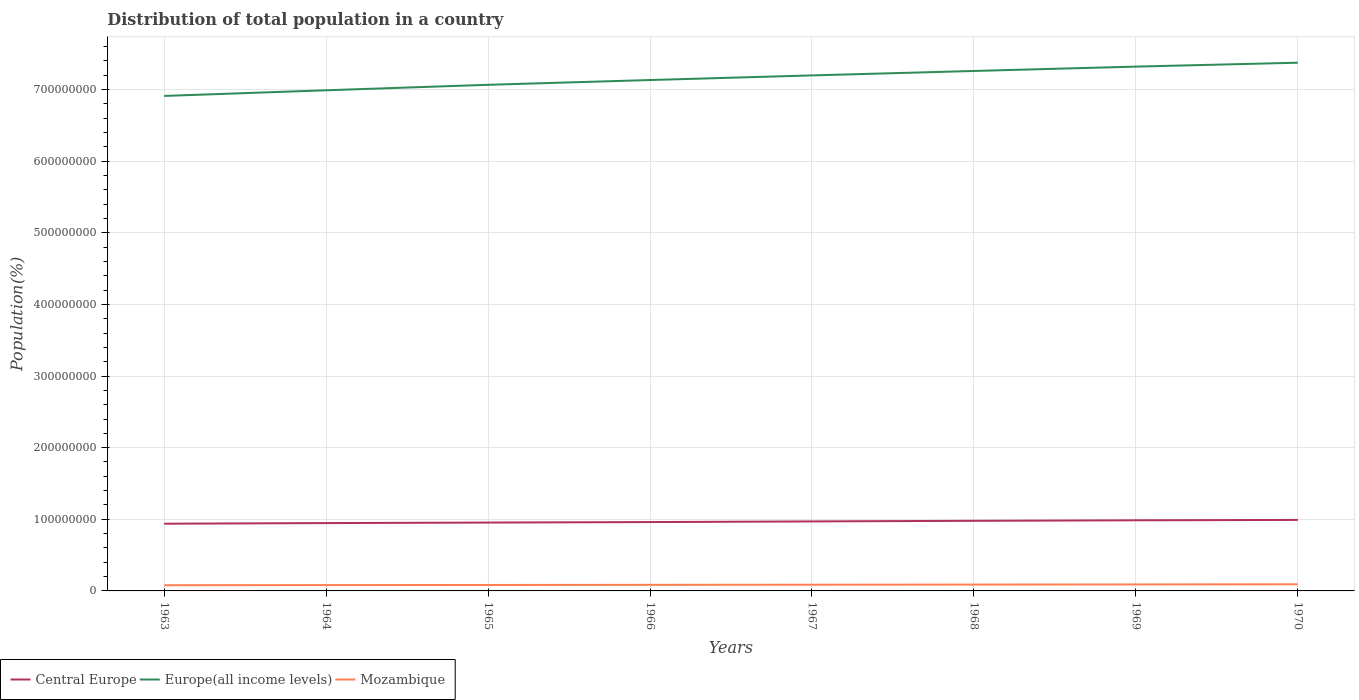How many different coloured lines are there?
Your answer should be compact. 3. Does the line corresponding to Mozambique intersect with the line corresponding to Central Europe?
Make the answer very short. No. Is the number of lines equal to the number of legend labels?
Your answer should be compact. Yes. Across all years, what is the maximum population of in Central Europe?
Give a very brief answer. 9.38e+07. In which year was the population of in Europe(all income levels) maximum?
Your response must be concise. 1963. What is the total population of in Mozambique in the graph?
Your answer should be very brief. -1.98e+05. What is the difference between the highest and the second highest population of in Central Europe?
Provide a short and direct response. 5.29e+06. Is the population of in Mozambique strictly greater than the population of in Europe(all income levels) over the years?
Provide a short and direct response. Yes. How many lines are there?
Provide a short and direct response. 3. What is the difference between two consecutive major ticks on the Y-axis?
Provide a succinct answer. 1.00e+08. Are the values on the major ticks of Y-axis written in scientific E-notation?
Your answer should be compact. No. Does the graph contain any zero values?
Offer a terse response. No. Does the graph contain grids?
Your answer should be compact. Yes. Where does the legend appear in the graph?
Your answer should be compact. Bottom left. How many legend labels are there?
Provide a succinct answer. 3. What is the title of the graph?
Your answer should be compact. Distribution of total population in a country. What is the label or title of the X-axis?
Ensure brevity in your answer.  Years. What is the label or title of the Y-axis?
Provide a succinct answer. Population(%). What is the Population(%) in Central Europe in 1963?
Keep it short and to the point. 9.38e+07. What is the Population(%) of Europe(all income levels) in 1963?
Provide a succinct answer. 6.91e+08. What is the Population(%) of Mozambique in 1963?
Offer a terse response. 7.96e+06. What is the Population(%) of Central Europe in 1964?
Your answer should be very brief. 9.47e+07. What is the Population(%) of Europe(all income levels) in 1964?
Your answer should be very brief. 6.99e+08. What is the Population(%) of Mozambique in 1964?
Your response must be concise. 8.13e+06. What is the Population(%) in Central Europe in 1965?
Offer a terse response. 9.54e+07. What is the Population(%) in Europe(all income levels) in 1965?
Ensure brevity in your answer.  7.07e+08. What is the Population(%) in Mozambique in 1965?
Provide a short and direct response. 8.30e+06. What is the Population(%) in Central Europe in 1966?
Ensure brevity in your answer.  9.61e+07. What is the Population(%) of Europe(all income levels) in 1966?
Offer a very short reply. 7.13e+08. What is the Population(%) in Mozambique in 1966?
Provide a short and direct response. 8.48e+06. What is the Population(%) in Central Europe in 1967?
Give a very brief answer. 9.70e+07. What is the Population(%) of Europe(all income levels) in 1967?
Keep it short and to the point. 7.20e+08. What is the Population(%) in Mozambique in 1967?
Offer a terse response. 8.67e+06. What is the Population(%) of Central Europe in 1968?
Your answer should be very brief. 9.79e+07. What is the Population(%) in Europe(all income levels) in 1968?
Keep it short and to the point. 7.26e+08. What is the Population(%) in Mozambique in 1968?
Give a very brief answer. 8.86e+06. What is the Population(%) of Central Europe in 1969?
Provide a succinct answer. 9.86e+07. What is the Population(%) of Europe(all income levels) in 1969?
Give a very brief answer. 7.32e+08. What is the Population(%) in Mozambique in 1969?
Make the answer very short. 9.06e+06. What is the Population(%) of Central Europe in 1970?
Offer a very short reply. 9.91e+07. What is the Population(%) of Europe(all income levels) in 1970?
Keep it short and to the point. 7.38e+08. What is the Population(%) of Mozambique in 1970?
Make the answer very short. 9.26e+06. Across all years, what is the maximum Population(%) in Central Europe?
Ensure brevity in your answer.  9.91e+07. Across all years, what is the maximum Population(%) in Europe(all income levels)?
Ensure brevity in your answer.  7.38e+08. Across all years, what is the maximum Population(%) in Mozambique?
Offer a terse response. 9.26e+06. Across all years, what is the minimum Population(%) of Central Europe?
Your answer should be compact. 9.38e+07. Across all years, what is the minimum Population(%) in Europe(all income levels)?
Ensure brevity in your answer.  6.91e+08. Across all years, what is the minimum Population(%) of Mozambique?
Provide a succinct answer. 7.96e+06. What is the total Population(%) in Central Europe in the graph?
Ensure brevity in your answer.  7.73e+08. What is the total Population(%) in Europe(all income levels) in the graph?
Provide a short and direct response. 5.73e+09. What is the total Population(%) of Mozambique in the graph?
Offer a terse response. 6.87e+07. What is the difference between the Population(%) in Central Europe in 1963 and that in 1964?
Your response must be concise. -8.77e+05. What is the difference between the Population(%) in Europe(all income levels) in 1963 and that in 1964?
Offer a very short reply. -7.90e+06. What is the difference between the Population(%) in Mozambique in 1963 and that in 1964?
Provide a succinct answer. -1.68e+05. What is the difference between the Population(%) in Central Europe in 1963 and that in 1965?
Your answer should be compact. -1.60e+06. What is the difference between the Population(%) in Europe(all income levels) in 1963 and that in 1965?
Provide a short and direct response. -1.55e+07. What is the difference between the Population(%) in Mozambique in 1963 and that in 1965?
Keep it short and to the point. -3.41e+05. What is the difference between the Population(%) of Central Europe in 1963 and that in 1966?
Make the answer very short. -2.30e+06. What is the difference between the Population(%) of Europe(all income levels) in 1963 and that in 1966?
Keep it short and to the point. -2.22e+07. What is the difference between the Population(%) of Mozambique in 1963 and that in 1966?
Offer a terse response. -5.21e+05. What is the difference between the Population(%) of Central Europe in 1963 and that in 1967?
Ensure brevity in your answer.  -3.20e+06. What is the difference between the Population(%) in Europe(all income levels) in 1963 and that in 1967?
Provide a short and direct response. -2.87e+07. What is the difference between the Population(%) of Mozambique in 1963 and that in 1967?
Ensure brevity in your answer.  -7.07e+05. What is the difference between the Population(%) in Central Europe in 1963 and that in 1968?
Provide a short and direct response. -4.04e+06. What is the difference between the Population(%) in Europe(all income levels) in 1963 and that in 1968?
Provide a succinct answer. -3.48e+07. What is the difference between the Population(%) of Mozambique in 1963 and that in 1968?
Your response must be concise. -8.99e+05. What is the difference between the Population(%) in Central Europe in 1963 and that in 1969?
Ensure brevity in your answer.  -4.76e+06. What is the difference between the Population(%) of Europe(all income levels) in 1963 and that in 1969?
Offer a very short reply. -4.09e+07. What is the difference between the Population(%) in Mozambique in 1963 and that in 1969?
Offer a very short reply. -1.10e+06. What is the difference between the Population(%) of Central Europe in 1963 and that in 1970?
Your answer should be very brief. -5.29e+06. What is the difference between the Population(%) of Europe(all income levels) in 1963 and that in 1970?
Make the answer very short. -4.64e+07. What is the difference between the Population(%) of Mozambique in 1963 and that in 1970?
Provide a succinct answer. -1.30e+06. What is the difference between the Population(%) of Central Europe in 1964 and that in 1965?
Offer a terse response. -7.24e+05. What is the difference between the Population(%) of Europe(all income levels) in 1964 and that in 1965?
Provide a succinct answer. -7.64e+06. What is the difference between the Population(%) in Mozambique in 1964 and that in 1965?
Provide a short and direct response. -1.73e+05. What is the difference between the Population(%) of Central Europe in 1964 and that in 1966?
Your answer should be very brief. -1.43e+06. What is the difference between the Population(%) of Europe(all income levels) in 1964 and that in 1966?
Provide a succinct answer. -1.43e+07. What is the difference between the Population(%) of Mozambique in 1964 and that in 1966?
Provide a short and direct response. -3.53e+05. What is the difference between the Population(%) of Central Europe in 1964 and that in 1967?
Ensure brevity in your answer.  -2.32e+06. What is the difference between the Population(%) in Europe(all income levels) in 1964 and that in 1967?
Provide a succinct answer. -2.08e+07. What is the difference between the Population(%) of Mozambique in 1964 and that in 1967?
Provide a short and direct response. -5.39e+05. What is the difference between the Population(%) in Central Europe in 1964 and that in 1968?
Provide a succinct answer. -3.16e+06. What is the difference between the Population(%) of Europe(all income levels) in 1964 and that in 1968?
Make the answer very short. -2.70e+07. What is the difference between the Population(%) of Mozambique in 1964 and that in 1968?
Your response must be concise. -7.32e+05. What is the difference between the Population(%) in Central Europe in 1964 and that in 1969?
Your answer should be compact. -3.88e+06. What is the difference between the Population(%) of Europe(all income levels) in 1964 and that in 1969?
Provide a succinct answer. -3.30e+07. What is the difference between the Population(%) in Mozambique in 1964 and that in 1969?
Make the answer very short. -9.29e+05. What is the difference between the Population(%) of Central Europe in 1964 and that in 1970?
Ensure brevity in your answer.  -4.41e+06. What is the difference between the Population(%) of Europe(all income levels) in 1964 and that in 1970?
Provide a succinct answer. -3.85e+07. What is the difference between the Population(%) of Mozambique in 1964 and that in 1970?
Offer a very short reply. -1.13e+06. What is the difference between the Population(%) of Central Europe in 1965 and that in 1966?
Give a very brief answer. -7.02e+05. What is the difference between the Population(%) in Europe(all income levels) in 1965 and that in 1966?
Offer a terse response. -6.66e+06. What is the difference between the Population(%) in Mozambique in 1965 and that in 1966?
Offer a very short reply. -1.80e+05. What is the difference between the Population(%) of Central Europe in 1965 and that in 1967?
Provide a short and direct response. -1.60e+06. What is the difference between the Population(%) in Europe(all income levels) in 1965 and that in 1967?
Your answer should be very brief. -1.31e+07. What is the difference between the Population(%) in Mozambique in 1965 and that in 1967?
Provide a short and direct response. -3.66e+05. What is the difference between the Population(%) in Central Europe in 1965 and that in 1968?
Keep it short and to the point. -2.44e+06. What is the difference between the Population(%) of Europe(all income levels) in 1965 and that in 1968?
Offer a very short reply. -1.93e+07. What is the difference between the Population(%) in Mozambique in 1965 and that in 1968?
Ensure brevity in your answer.  -5.58e+05. What is the difference between the Population(%) in Central Europe in 1965 and that in 1969?
Make the answer very short. -3.16e+06. What is the difference between the Population(%) in Europe(all income levels) in 1965 and that in 1969?
Keep it short and to the point. -2.54e+07. What is the difference between the Population(%) in Mozambique in 1965 and that in 1969?
Provide a succinct answer. -7.56e+05. What is the difference between the Population(%) in Central Europe in 1965 and that in 1970?
Keep it short and to the point. -3.69e+06. What is the difference between the Population(%) of Europe(all income levels) in 1965 and that in 1970?
Your response must be concise. -3.09e+07. What is the difference between the Population(%) of Mozambique in 1965 and that in 1970?
Ensure brevity in your answer.  -9.59e+05. What is the difference between the Population(%) in Central Europe in 1966 and that in 1967?
Provide a short and direct response. -8.95e+05. What is the difference between the Population(%) of Europe(all income levels) in 1966 and that in 1967?
Offer a terse response. -6.45e+06. What is the difference between the Population(%) in Mozambique in 1966 and that in 1967?
Your answer should be compact. -1.86e+05. What is the difference between the Population(%) of Central Europe in 1966 and that in 1968?
Provide a succinct answer. -1.73e+06. What is the difference between the Population(%) of Europe(all income levels) in 1966 and that in 1968?
Provide a short and direct response. -1.26e+07. What is the difference between the Population(%) of Mozambique in 1966 and that in 1968?
Give a very brief answer. -3.78e+05. What is the difference between the Population(%) of Central Europe in 1966 and that in 1969?
Your response must be concise. -2.45e+06. What is the difference between the Population(%) of Europe(all income levels) in 1966 and that in 1969?
Ensure brevity in your answer.  -1.87e+07. What is the difference between the Population(%) of Mozambique in 1966 and that in 1969?
Offer a terse response. -5.76e+05. What is the difference between the Population(%) in Central Europe in 1966 and that in 1970?
Provide a short and direct response. -2.98e+06. What is the difference between the Population(%) in Europe(all income levels) in 1966 and that in 1970?
Provide a succinct answer. -2.42e+07. What is the difference between the Population(%) of Mozambique in 1966 and that in 1970?
Your answer should be compact. -7.80e+05. What is the difference between the Population(%) of Central Europe in 1967 and that in 1968?
Your answer should be very brief. -8.39e+05. What is the difference between the Population(%) of Europe(all income levels) in 1967 and that in 1968?
Your answer should be very brief. -6.20e+06. What is the difference between the Population(%) of Mozambique in 1967 and that in 1968?
Offer a very short reply. -1.92e+05. What is the difference between the Population(%) of Central Europe in 1967 and that in 1969?
Ensure brevity in your answer.  -1.56e+06. What is the difference between the Population(%) of Europe(all income levels) in 1967 and that in 1969?
Your answer should be very brief. -1.23e+07. What is the difference between the Population(%) of Mozambique in 1967 and that in 1969?
Give a very brief answer. -3.90e+05. What is the difference between the Population(%) of Central Europe in 1967 and that in 1970?
Make the answer very short. -2.09e+06. What is the difference between the Population(%) of Europe(all income levels) in 1967 and that in 1970?
Your response must be concise. -1.77e+07. What is the difference between the Population(%) in Mozambique in 1967 and that in 1970?
Your response must be concise. -5.94e+05. What is the difference between the Population(%) of Central Europe in 1968 and that in 1969?
Offer a very short reply. -7.20e+05. What is the difference between the Population(%) of Europe(all income levels) in 1968 and that in 1969?
Ensure brevity in your answer.  -6.10e+06. What is the difference between the Population(%) of Mozambique in 1968 and that in 1969?
Provide a short and direct response. -1.98e+05. What is the difference between the Population(%) of Central Europe in 1968 and that in 1970?
Ensure brevity in your answer.  -1.25e+06. What is the difference between the Population(%) in Europe(all income levels) in 1968 and that in 1970?
Ensure brevity in your answer.  -1.16e+07. What is the difference between the Population(%) in Mozambique in 1968 and that in 1970?
Offer a very short reply. -4.01e+05. What is the difference between the Population(%) in Central Europe in 1969 and that in 1970?
Offer a terse response. -5.31e+05. What is the difference between the Population(%) in Europe(all income levels) in 1969 and that in 1970?
Ensure brevity in your answer.  -5.46e+06. What is the difference between the Population(%) of Mozambique in 1969 and that in 1970?
Offer a very short reply. -2.03e+05. What is the difference between the Population(%) of Central Europe in 1963 and the Population(%) of Europe(all income levels) in 1964?
Make the answer very short. -6.05e+08. What is the difference between the Population(%) of Central Europe in 1963 and the Population(%) of Mozambique in 1964?
Keep it short and to the point. 8.57e+07. What is the difference between the Population(%) of Europe(all income levels) in 1963 and the Population(%) of Mozambique in 1964?
Ensure brevity in your answer.  6.83e+08. What is the difference between the Population(%) of Central Europe in 1963 and the Population(%) of Europe(all income levels) in 1965?
Ensure brevity in your answer.  -6.13e+08. What is the difference between the Population(%) of Central Europe in 1963 and the Population(%) of Mozambique in 1965?
Provide a short and direct response. 8.55e+07. What is the difference between the Population(%) in Europe(all income levels) in 1963 and the Population(%) in Mozambique in 1965?
Offer a terse response. 6.83e+08. What is the difference between the Population(%) of Central Europe in 1963 and the Population(%) of Europe(all income levels) in 1966?
Offer a very short reply. -6.19e+08. What is the difference between the Population(%) in Central Europe in 1963 and the Population(%) in Mozambique in 1966?
Offer a very short reply. 8.54e+07. What is the difference between the Population(%) in Europe(all income levels) in 1963 and the Population(%) in Mozambique in 1966?
Give a very brief answer. 6.83e+08. What is the difference between the Population(%) of Central Europe in 1963 and the Population(%) of Europe(all income levels) in 1967?
Give a very brief answer. -6.26e+08. What is the difference between the Population(%) of Central Europe in 1963 and the Population(%) of Mozambique in 1967?
Give a very brief answer. 8.52e+07. What is the difference between the Population(%) in Europe(all income levels) in 1963 and the Population(%) in Mozambique in 1967?
Your answer should be very brief. 6.82e+08. What is the difference between the Population(%) of Central Europe in 1963 and the Population(%) of Europe(all income levels) in 1968?
Offer a terse response. -6.32e+08. What is the difference between the Population(%) in Central Europe in 1963 and the Population(%) in Mozambique in 1968?
Your response must be concise. 8.50e+07. What is the difference between the Population(%) of Europe(all income levels) in 1963 and the Population(%) of Mozambique in 1968?
Keep it short and to the point. 6.82e+08. What is the difference between the Population(%) in Central Europe in 1963 and the Population(%) in Europe(all income levels) in 1969?
Offer a terse response. -6.38e+08. What is the difference between the Population(%) of Central Europe in 1963 and the Population(%) of Mozambique in 1969?
Ensure brevity in your answer.  8.48e+07. What is the difference between the Population(%) in Europe(all income levels) in 1963 and the Population(%) in Mozambique in 1969?
Your answer should be very brief. 6.82e+08. What is the difference between the Population(%) of Central Europe in 1963 and the Population(%) of Europe(all income levels) in 1970?
Ensure brevity in your answer.  -6.44e+08. What is the difference between the Population(%) in Central Europe in 1963 and the Population(%) in Mozambique in 1970?
Ensure brevity in your answer.  8.46e+07. What is the difference between the Population(%) in Europe(all income levels) in 1963 and the Population(%) in Mozambique in 1970?
Your response must be concise. 6.82e+08. What is the difference between the Population(%) of Central Europe in 1964 and the Population(%) of Europe(all income levels) in 1965?
Your answer should be very brief. -6.12e+08. What is the difference between the Population(%) in Central Europe in 1964 and the Population(%) in Mozambique in 1965?
Offer a very short reply. 8.64e+07. What is the difference between the Population(%) of Europe(all income levels) in 1964 and the Population(%) of Mozambique in 1965?
Offer a terse response. 6.91e+08. What is the difference between the Population(%) of Central Europe in 1964 and the Population(%) of Europe(all income levels) in 1966?
Your answer should be compact. -6.19e+08. What is the difference between the Population(%) in Central Europe in 1964 and the Population(%) in Mozambique in 1966?
Provide a short and direct response. 8.62e+07. What is the difference between the Population(%) in Europe(all income levels) in 1964 and the Population(%) in Mozambique in 1966?
Make the answer very short. 6.91e+08. What is the difference between the Population(%) in Central Europe in 1964 and the Population(%) in Europe(all income levels) in 1967?
Keep it short and to the point. -6.25e+08. What is the difference between the Population(%) of Central Europe in 1964 and the Population(%) of Mozambique in 1967?
Ensure brevity in your answer.  8.61e+07. What is the difference between the Population(%) in Europe(all income levels) in 1964 and the Population(%) in Mozambique in 1967?
Your answer should be very brief. 6.90e+08. What is the difference between the Population(%) of Central Europe in 1964 and the Population(%) of Europe(all income levels) in 1968?
Your answer should be very brief. -6.31e+08. What is the difference between the Population(%) in Central Europe in 1964 and the Population(%) in Mozambique in 1968?
Your response must be concise. 8.59e+07. What is the difference between the Population(%) in Europe(all income levels) in 1964 and the Population(%) in Mozambique in 1968?
Make the answer very short. 6.90e+08. What is the difference between the Population(%) in Central Europe in 1964 and the Population(%) in Europe(all income levels) in 1969?
Provide a succinct answer. -6.37e+08. What is the difference between the Population(%) of Central Europe in 1964 and the Population(%) of Mozambique in 1969?
Offer a very short reply. 8.57e+07. What is the difference between the Population(%) in Europe(all income levels) in 1964 and the Population(%) in Mozambique in 1969?
Your answer should be very brief. 6.90e+08. What is the difference between the Population(%) in Central Europe in 1964 and the Population(%) in Europe(all income levels) in 1970?
Provide a succinct answer. -6.43e+08. What is the difference between the Population(%) of Central Europe in 1964 and the Population(%) of Mozambique in 1970?
Offer a terse response. 8.55e+07. What is the difference between the Population(%) of Europe(all income levels) in 1964 and the Population(%) of Mozambique in 1970?
Give a very brief answer. 6.90e+08. What is the difference between the Population(%) of Central Europe in 1965 and the Population(%) of Europe(all income levels) in 1966?
Ensure brevity in your answer.  -6.18e+08. What is the difference between the Population(%) of Central Europe in 1965 and the Population(%) of Mozambique in 1966?
Ensure brevity in your answer.  8.70e+07. What is the difference between the Population(%) in Europe(all income levels) in 1965 and the Population(%) in Mozambique in 1966?
Offer a very short reply. 6.98e+08. What is the difference between the Population(%) in Central Europe in 1965 and the Population(%) in Europe(all income levels) in 1967?
Offer a terse response. -6.24e+08. What is the difference between the Population(%) of Central Europe in 1965 and the Population(%) of Mozambique in 1967?
Offer a terse response. 8.68e+07. What is the difference between the Population(%) of Europe(all income levels) in 1965 and the Population(%) of Mozambique in 1967?
Keep it short and to the point. 6.98e+08. What is the difference between the Population(%) of Central Europe in 1965 and the Population(%) of Europe(all income levels) in 1968?
Keep it short and to the point. -6.31e+08. What is the difference between the Population(%) in Central Europe in 1965 and the Population(%) in Mozambique in 1968?
Offer a terse response. 8.66e+07. What is the difference between the Population(%) in Europe(all income levels) in 1965 and the Population(%) in Mozambique in 1968?
Offer a very short reply. 6.98e+08. What is the difference between the Population(%) of Central Europe in 1965 and the Population(%) of Europe(all income levels) in 1969?
Provide a succinct answer. -6.37e+08. What is the difference between the Population(%) of Central Europe in 1965 and the Population(%) of Mozambique in 1969?
Keep it short and to the point. 8.64e+07. What is the difference between the Population(%) in Europe(all income levels) in 1965 and the Population(%) in Mozambique in 1969?
Your answer should be compact. 6.98e+08. What is the difference between the Population(%) in Central Europe in 1965 and the Population(%) in Europe(all income levels) in 1970?
Ensure brevity in your answer.  -6.42e+08. What is the difference between the Population(%) of Central Europe in 1965 and the Population(%) of Mozambique in 1970?
Provide a succinct answer. 8.62e+07. What is the difference between the Population(%) in Europe(all income levels) in 1965 and the Population(%) in Mozambique in 1970?
Your answer should be very brief. 6.97e+08. What is the difference between the Population(%) in Central Europe in 1966 and the Population(%) in Europe(all income levels) in 1967?
Make the answer very short. -6.24e+08. What is the difference between the Population(%) in Central Europe in 1966 and the Population(%) in Mozambique in 1967?
Offer a very short reply. 8.75e+07. What is the difference between the Population(%) in Europe(all income levels) in 1966 and the Population(%) in Mozambique in 1967?
Your answer should be very brief. 7.05e+08. What is the difference between the Population(%) in Central Europe in 1966 and the Population(%) in Europe(all income levels) in 1968?
Keep it short and to the point. -6.30e+08. What is the difference between the Population(%) in Central Europe in 1966 and the Population(%) in Mozambique in 1968?
Give a very brief answer. 8.73e+07. What is the difference between the Population(%) of Europe(all income levels) in 1966 and the Population(%) of Mozambique in 1968?
Your answer should be very brief. 7.04e+08. What is the difference between the Population(%) in Central Europe in 1966 and the Population(%) in Europe(all income levels) in 1969?
Make the answer very short. -6.36e+08. What is the difference between the Population(%) in Central Europe in 1966 and the Population(%) in Mozambique in 1969?
Offer a very short reply. 8.71e+07. What is the difference between the Population(%) of Europe(all income levels) in 1966 and the Population(%) of Mozambique in 1969?
Ensure brevity in your answer.  7.04e+08. What is the difference between the Population(%) in Central Europe in 1966 and the Population(%) in Europe(all income levels) in 1970?
Your answer should be compact. -6.41e+08. What is the difference between the Population(%) of Central Europe in 1966 and the Population(%) of Mozambique in 1970?
Make the answer very short. 8.69e+07. What is the difference between the Population(%) of Europe(all income levels) in 1966 and the Population(%) of Mozambique in 1970?
Ensure brevity in your answer.  7.04e+08. What is the difference between the Population(%) in Central Europe in 1967 and the Population(%) in Europe(all income levels) in 1968?
Offer a terse response. -6.29e+08. What is the difference between the Population(%) in Central Europe in 1967 and the Population(%) in Mozambique in 1968?
Your answer should be compact. 8.82e+07. What is the difference between the Population(%) of Europe(all income levels) in 1967 and the Population(%) of Mozambique in 1968?
Offer a terse response. 7.11e+08. What is the difference between the Population(%) of Central Europe in 1967 and the Population(%) of Europe(all income levels) in 1969?
Your response must be concise. -6.35e+08. What is the difference between the Population(%) of Central Europe in 1967 and the Population(%) of Mozambique in 1969?
Your answer should be compact. 8.80e+07. What is the difference between the Population(%) of Europe(all income levels) in 1967 and the Population(%) of Mozambique in 1969?
Give a very brief answer. 7.11e+08. What is the difference between the Population(%) of Central Europe in 1967 and the Population(%) of Europe(all income levels) in 1970?
Keep it short and to the point. -6.40e+08. What is the difference between the Population(%) of Central Europe in 1967 and the Population(%) of Mozambique in 1970?
Your response must be concise. 8.78e+07. What is the difference between the Population(%) in Europe(all income levels) in 1967 and the Population(%) in Mozambique in 1970?
Provide a short and direct response. 7.10e+08. What is the difference between the Population(%) in Central Europe in 1968 and the Population(%) in Europe(all income levels) in 1969?
Your answer should be very brief. -6.34e+08. What is the difference between the Population(%) in Central Europe in 1968 and the Population(%) in Mozambique in 1969?
Provide a succinct answer. 8.88e+07. What is the difference between the Population(%) in Europe(all income levels) in 1968 and the Population(%) in Mozambique in 1969?
Provide a short and direct response. 7.17e+08. What is the difference between the Population(%) of Central Europe in 1968 and the Population(%) of Europe(all income levels) in 1970?
Give a very brief answer. -6.40e+08. What is the difference between the Population(%) in Central Europe in 1968 and the Population(%) in Mozambique in 1970?
Provide a succinct answer. 8.86e+07. What is the difference between the Population(%) of Europe(all income levels) in 1968 and the Population(%) of Mozambique in 1970?
Offer a very short reply. 7.17e+08. What is the difference between the Population(%) of Central Europe in 1969 and the Population(%) of Europe(all income levels) in 1970?
Your answer should be very brief. -6.39e+08. What is the difference between the Population(%) in Central Europe in 1969 and the Population(%) in Mozambique in 1970?
Offer a terse response. 8.93e+07. What is the difference between the Population(%) of Europe(all income levels) in 1969 and the Population(%) of Mozambique in 1970?
Provide a succinct answer. 7.23e+08. What is the average Population(%) of Central Europe per year?
Your response must be concise. 9.66e+07. What is the average Population(%) of Europe(all income levels) per year?
Give a very brief answer. 7.16e+08. What is the average Population(%) of Mozambique per year?
Make the answer very short. 8.59e+06. In the year 1963, what is the difference between the Population(%) in Central Europe and Population(%) in Europe(all income levels)?
Provide a succinct answer. -5.97e+08. In the year 1963, what is the difference between the Population(%) of Central Europe and Population(%) of Mozambique?
Offer a very short reply. 8.59e+07. In the year 1963, what is the difference between the Population(%) of Europe(all income levels) and Population(%) of Mozambique?
Offer a very short reply. 6.83e+08. In the year 1964, what is the difference between the Population(%) in Central Europe and Population(%) in Europe(all income levels)?
Ensure brevity in your answer.  -6.04e+08. In the year 1964, what is the difference between the Population(%) in Central Europe and Population(%) in Mozambique?
Offer a very short reply. 8.66e+07. In the year 1964, what is the difference between the Population(%) in Europe(all income levels) and Population(%) in Mozambique?
Your answer should be very brief. 6.91e+08. In the year 1965, what is the difference between the Population(%) in Central Europe and Population(%) in Europe(all income levels)?
Provide a succinct answer. -6.11e+08. In the year 1965, what is the difference between the Population(%) of Central Europe and Population(%) of Mozambique?
Your response must be concise. 8.71e+07. In the year 1965, what is the difference between the Population(%) of Europe(all income levels) and Population(%) of Mozambique?
Provide a short and direct response. 6.98e+08. In the year 1966, what is the difference between the Population(%) of Central Europe and Population(%) of Europe(all income levels)?
Offer a very short reply. -6.17e+08. In the year 1966, what is the difference between the Population(%) in Central Europe and Population(%) in Mozambique?
Keep it short and to the point. 8.77e+07. In the year 1966, what is the difference between the Population(%) of Europe(all income levels) and Population(%) of Mozambique?
Provide a short and direct response. 7.05e+08. In the year 1967, what is the difference between the Population(%) in Central Europe and Population(%) in Europe(all income levels)?
Offer a terse response. -6.23e+08. In the year 1967, what is the difference between the Population(%) of Central Europe and Population(%) of Mozambique?
Your answer should be very brief. 8.84e+07. In the year 1967, what is the difference between the Population(%) of Europe(all income levels) and Population(%) of Mozambique?
Offer a very short reply. 7.11e+08. In the year 1968, what is the difference between the Population(%) of Central Europe and Population(%) of Europe(all income levels)?
Make the answer very short. -6.28e+08. In the year 1968, what is the difference between the Population(%) of Central Europe and Population(%) of Mozambique?
Your answer should be compact. 8.90e+07. In the year 1968, what is the difference between the Population(%) in Europe(all income levels) and Population(%) in Mozambique?
Keep it short and to the point. 7.17e+08. In the year 1969, what is the difference between the Population(%) in Central Europe and Population(%) in Europe(all income levels)?
Provide a succinct answer. -6.33e+08. In the year 1969, what is the difference between the Population(%) of Central Europe and Population(%) of Mozambique?
Keep it short and to the point. 8.95e+07. In the year 1969, what is the difference between the Population(%) in Europe(all income levels) and Population(%) in Mozambique?
Give a very brief answer. 7.23e+08. In the year 1970, what is the difference between the Population(%) of Central Europe and Population(%) of Europe(all income levels)?
Your answer should be very brief. -6.38e+08. In the year 1970, what is the difference between the Population(%) of Central Europe and Population(%) of Mozambique?
Your answer should be compact. 8.99e+07. In the year 1970, what is the difference between the Population(%) of Europe(all income levels) and Population(%) of Mozambique?
Make the answer very short. 7.28e+08. What is the ratio of the Population(%) in Europe(all income levels) in 1963 to that in 1964?
Provide a short and direct response. 0.99. What is the ratio of the Population(%) in Mozambique in 1963 to that in 1964?
Your answer should be very brief. 0.98. What is the ratio of the Population(%) in Central Europe in 1963 to that in 1965?
Your answer should be compact. 0.98. What is the ratio of the Population(%) in Europe(all income levels) in 1963 to that in 1965?
Your response must be concise. 0.98. What is the ratio of the Population(%) in Mozambique in 1963 to that in 1965?
Provide a short and direct response. 0.96. What is the ratio of the Population(%) in Europe(all income levels) in 1963 to that in 1966?
Ensure brevity in your answer.  0.97. What is the ratio of the Population(%) of Mozambique in 1963 to that in 1966?
Provide a short and direct response. 0.94. What is the ratio of the Population(%) in Europe(all income levels) in 1963 to that in 1967?
Make the answer very short. 0.96. What is the ratio of the Population(%) of Mozambique in 1963 to that in 1967?
Provide a succinct answer. 0.92. What is the ratio of the Population(%) of Central Europe in 1963 to that in 1968?
Provide a short and direct response. 0.96. What is the ratio of the Population(%) of Europe(all income levels) in 1963 to that in 1968?
Make the answer very short. 0.95. What is the ratio of the Population(%) of Mozambique in 1963 to that in 1968?
Keep it short and to the point. 0.9. What is the ratio of the Population(%) of Central Europe in 1963 to that in 1969?
Your response must be concise. 0.95. What is the ratio of the Population(%) in Europe(all income levels) in 1963 to that in 1969?
Keep it short and to the point. 0.94. What is the ratio of the Population(%) of Mozambique in 1963 to that in 1969?
Ensure brevity in your answer.  0.88. What is the ratio of the Population(%) of Central Europe in 1963 to that in 1970?
Your response must be concise. 0.95. What is the ratio of the Population(%) of Europe(all income levels) in 1963 to that in 1970?
Your answer should be very brief. 0.94. What is the ratio of the Population(%) in Mozambique in 1963 to that in 1970?
Make the answer very short. 0.86. What is the ratio of the Population(%) in Mozambique in 1964 to that in 1965?
Your answer should be compact. 0.98. What is the ratio of the Population(%) in Central Europe in 1964 to that in 1966?
Your answer should be very brief. 0.99. What is the ratio of the Population(%) in Europe(all income levels) in 1964 to that in 1966?
Your response must be concise. 0.98. What is the ratio of the Population(%) in Mozambique in 1964 to that in 1966?
Give a very brief answer. 0.96. What is the ratio of the Population(%) of Central Europe in 1964 to that in 1967?
Make the answer very short. 0.98. What is the ratio of the Population(%) of Europe(all income levels) in 1964 to that in 1967?
Your answer should be very brief. 0.97. What is the ratio of the Population(%) of Mozambique in 1964 to that in 1967?
Keep it short and to the point. 0.94. What is the ratio of the Population(%) in Central Europe in 1964 to that in 1968?
Make the answer very short. 0.97. What is the ratio of the Population(%) of Europe(all income levels) in 1964 to that in 1968?
Your answer should be very brief. 0.96. What is the ratio of the Population(%) of Mozambique in 1964 to that in 1968?
Offer a very short reply. 0.92. What is the ratio of the Population(%) of Central Europe in 1964 to that in 1969?
Your answer should be compact. 0.96. What is the ratio of the Population(%) in Europe(all income levels) in 1964 to that in 1969?
Give a very brief answer. 0.95. What is the ratio of the Population(%) in Mozambique in 1964 to that in 1969?
Provide a succinct answer. 0.9. What is the ratio of the Population(%) of Central Europe in 1964 to that in 1970?
Provide a short and direct response. 0.96. What is the ratio of the Population(%) in Europe(all income levels) in 1964 to that in 1970?
Your response must be concise. 0.95. What is the ratio of the Population(%) in Mozambique in 1964 to that in 1970?
Your answer should be compact. 0.88. What is the ratio of the Population(%) of Mozambique in 1965 to that in 1966?
Provide a short and direct response. 0.98. What is the ratio of the Population(%) in Central Europe in 1965 to that in 1967?
Your answer should be compact. 0.98. What is the ratio of the Population(%) in Europe(all income levels) in 1965 to that in 1967?
Ensure brevity in your answer.  0.98. What is the ratio of the Population(%) of Mozambique in 1965 to that in 1967?
Provide a short and direct response. 0.96. What is the ratio of the Population(%) of Central Europe in 1965 to that in 1968?
Your response must be concise. 0.98. What is the ratio of the Population(%) in Europe(all income levels) in 1965 to that in 1968?
Give a very brief answer. 0.97. What is the ratio of the Population(%) of Mozambique in 1965 to that in 1968?
Give a very brief answer. 0.94. What is the ratio of the Population(%) of Europe(all income levels) in 1965 to that in 1969?
Your answer should be compact. 0.97. What is the ratio of the Population(%) in Mozambique in 1965 to that in 1969?
Give a very brief answer. 0.92. What is the ratio of the Population(%) of Central Europe in 1965 to that in 1970?
Make the answer very short. 0.96. What is the ratio of the Population(%) in Europe(all income levels) in 1965 to that in 1970?
Make the answer very short. 0.96. What is the ratio of the Population(%) in Mozambique in 1965 to that in 1970?
Your answer should be very brief. 0.9. What is the ratio of the Population(%) of Europe(all income levels) in 1966 to that in 1967?
Make the answer very short. 0.99. What is the ratio of the Population(%) in Mozambique in 1966 to that in 1967?
Offer a terse response. 0.98. What is the ratio of the Population(%) in Central Europe in 1966 to that in 1968?
Your answer should be compact. 0.98. What is the ratio of the Population(%) in Europe(all income levels) in 1966 to that in 1968?
Give a very brief answer. 0.98. What is the ratio of the Population(%) in Mozambique in 1966 to that in 1968?
Provide a succinct answer. 0.96. What is the ratio of the Population(%) in Central Europe in 1966 to that in 1969?
Give a very brief answer. 0.98. What is the ratio of the Population(%) of Europe(all income levels) in 1966 to that in 1969?
Offer a terse response. 0.97. What is the ratio of the Population(%) of Mozambique in 1966 to that in 1969?
Provide a short and direct response. 0.94. What is the ratio of the Population(%) of Central Europe in 1966 to that in 1970?
Provide a succinct answer. 0.97. What is the ratio of the Population(%) in Europe(all income levels) in 1966 to that in 1970?
Your answer should be compact. 0.97. What is the ratio of the Population(%) of Mozambique in 1966 to that in 1970?
Your answer should be compact. 0.92. What is the ratio of the Population(%) of Mozambique in 1967 to that in 1968?
Provide a succinct answer. 0.98. What is the ratio of the Population(%) in Central Europe in 1967 to that in 1969?
Offer a very short reply. 0.98. What is the ratio of the Population(%) of Europe(all income levels) in 1967 to that in 1969?
Offer a very short reply. 0.98. What is the ratio of the Population(%) of Mozambique in 1967 to that in 1969?
Provide a short and direct response. 0.96. What is the ratio of the Population(%) of Central Europe in 1967 to that in 1970?
Make the answer very short. 0.98. What is the ratio of the Population(%) of Europe(all income levels) in 1967 to that in 1970?
Provide a short and direct response. 0.98. What is the ratio of the Population(%) of Mozambique in 1967 to that in 1970?
Offer a very short reply. 0.94. What is the ratio of the Population(%) of Mozambique in 1968 to that in 1969?
Ensure brevity in your answer.  0.98. What is the ratio of the Population(%) of Central Europe in 1968 to that in 1970?
Your answer should be very brief. 0.99. What is the ratio of the Population(%) in Europe(all income levels) in 1968 to that in 1970?
Keep it short and to the point. 0.98. What is the ratio of the Population(%) in Mozambique in 1968 to that in 1970?
Keep it short and to the point. 0.96. What is the ratio of the Population(%) of Central Europe in 1969 to that in 1970?
Provide a short and direct response. 0.99. What is the ratio of the Population(%) of Europe(all income levels) in 1969 to that in 1970?
Keep it short and to the point. 0.99. What is the difference between the highest and the second highest Population(%) in Central Europe?
Make the answer very short. 5.31e+05. What is the difference between the highest and the second highest Population(%) of Europe(all income levels)?
Keep it short and to the point. 5.46e+06. What is the difference between the highest and the second highest Population(%) in Mozambique?
Your answer should be compact. 2.03e+05. What is the difference between the highest and the lowest Population(%) of Central Europe?
Ensure brevity in your answer.  5.29e+06. What is the difference between the highest and the lowest Population(%) in Europe(all income levels)?
Ensure brevity in your answer.  4.64e+07. What is the difference between the highest and the lowest Population(%) in Mozambique?
Offer a terse response. 1.30e+06. 